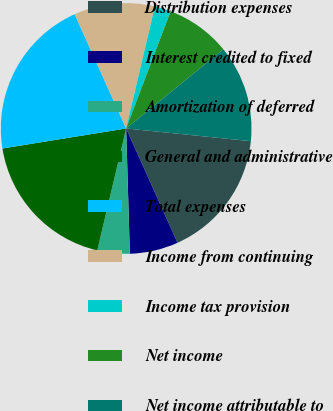<chart> <loc_0><loc_0><loc_500><loc_500><pie_chart><fcel>Distribution expenses<fcel>Interest credited to fixed<fcel>Amortization of deferred<fcel>General and administrative<fcel>Total expenses<fcel>Income from continuing<fcel>Income tax provision<fcel>Net income<fcel>Net income attributable to<nl><fcel>16.66%<fcel>6.25%<fcel>4.17%<fcel>18.74%<fcel>20.82%<fcel>10.42%<fcel>2.09%<fcel>8.34%<fcel>12.5%<nl></chart> 